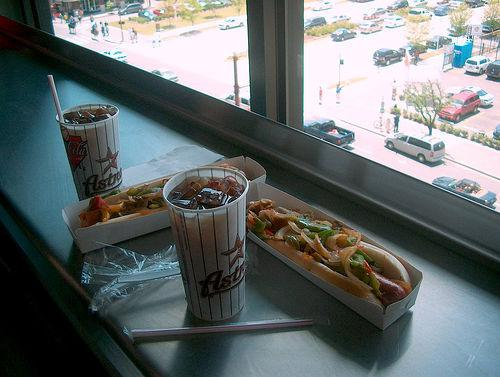What food is shown in the boats?

Choices:
A) pizza
B) hot dog
C) hamburger
D) tacos hot dog 